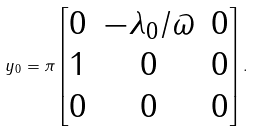<formula> <loc_0><loc_0><loc_500><loc_500>y _ { 0 } = \pi \begin{bmatrix} 0 & - \lambda _ { 0 } / \varpi & 0 \\ 1 & 0 & 0 \\ 0 & 0 & 0 \end{bmatrix} .</formula> 